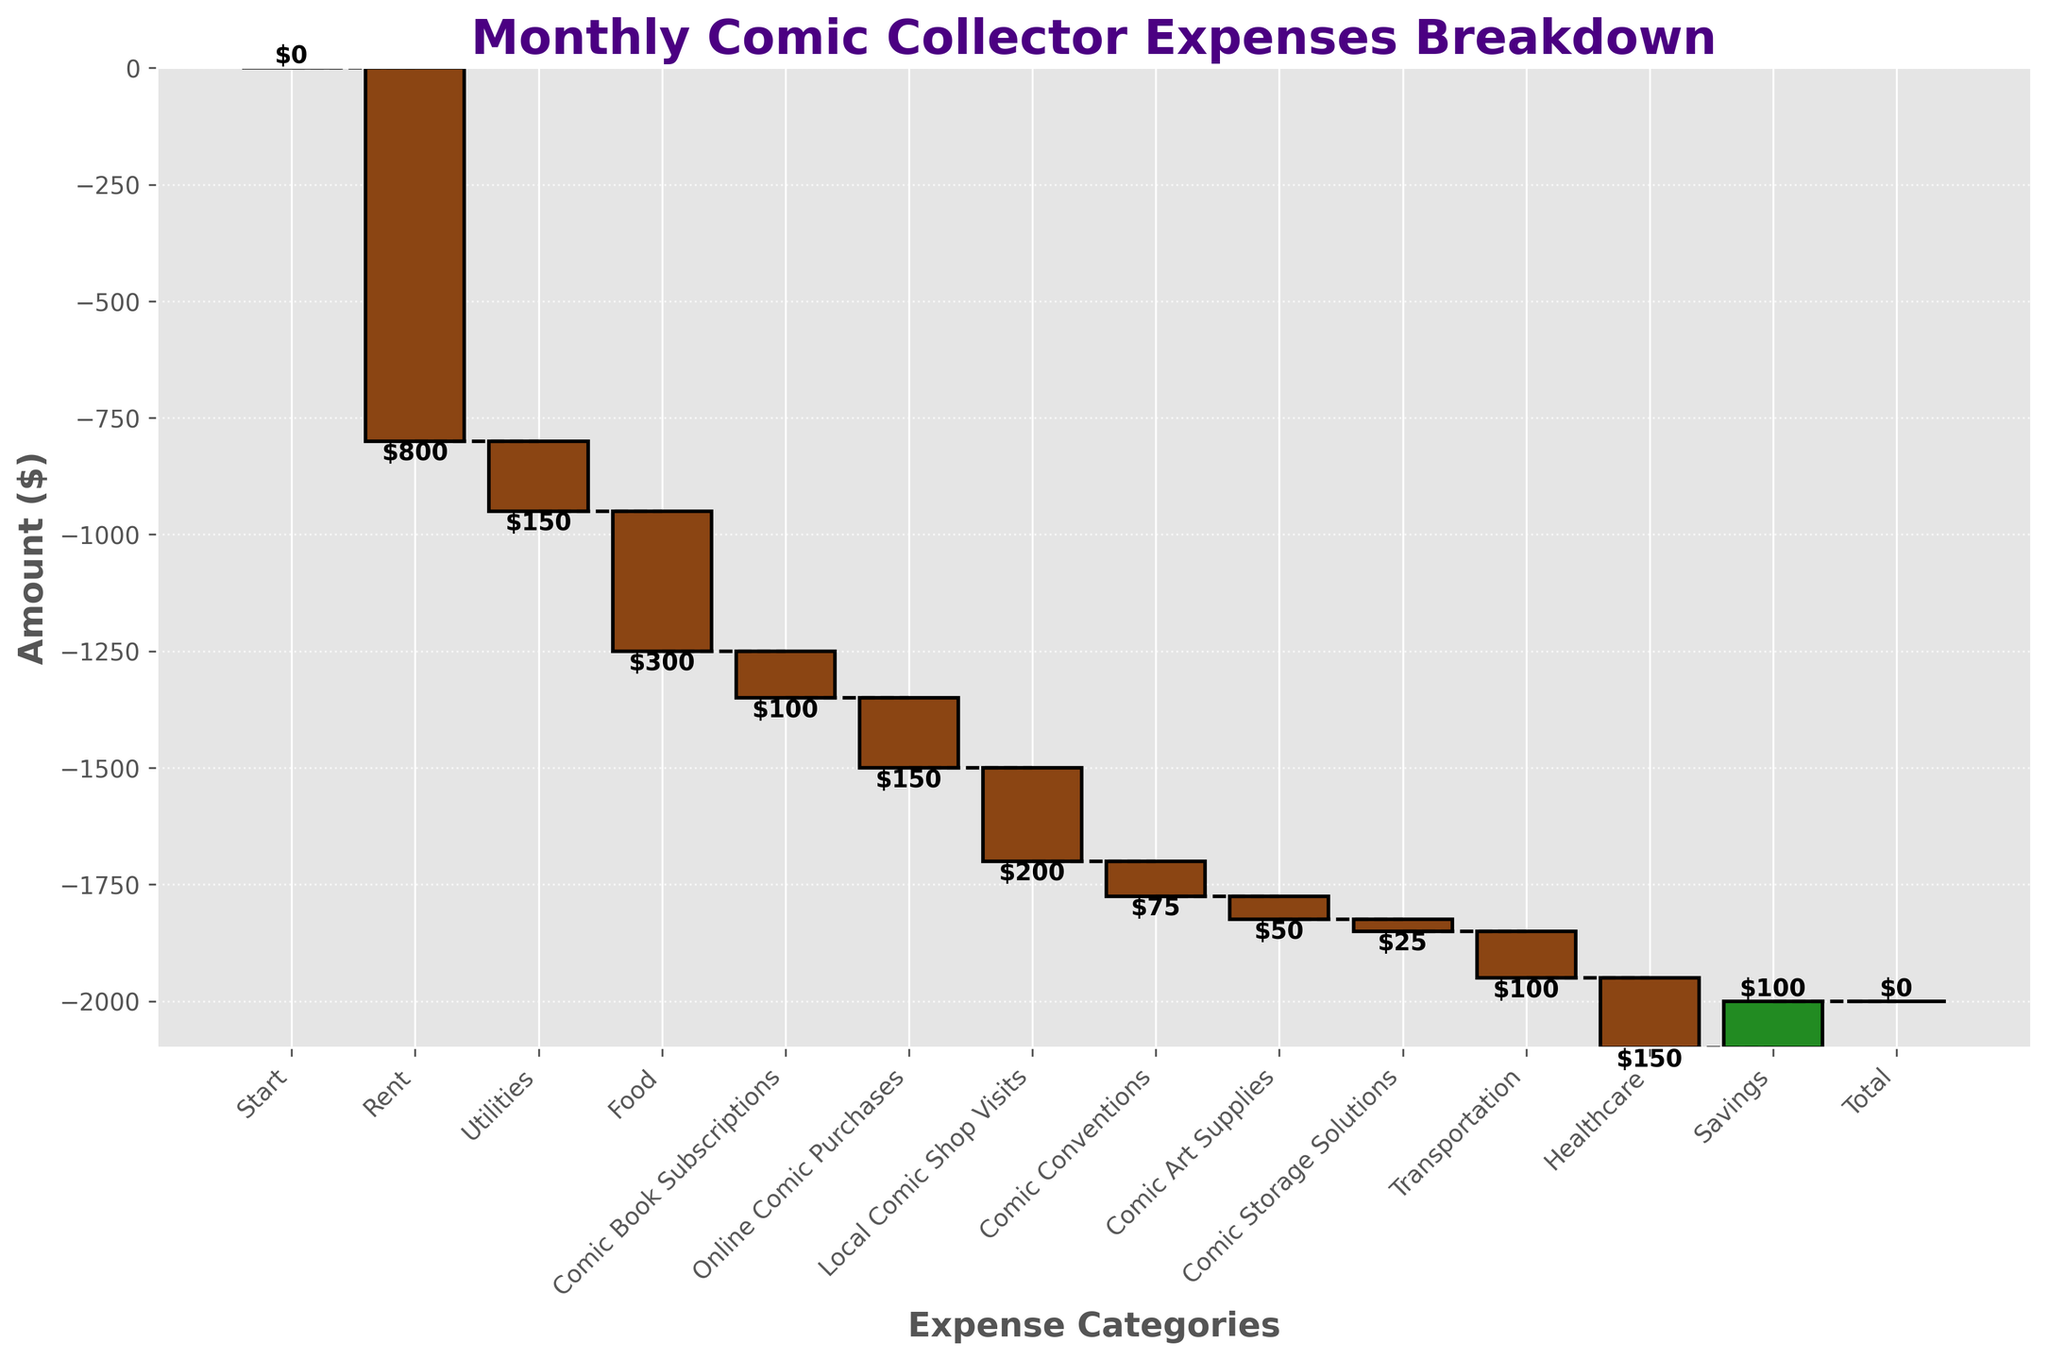What is the title of the chart? The title of the chart is found at the top part of the figure. It summarizes the entire plot.
Answer: Monthly Comic Collector Expenses Breakdown How many categories have negative amounts? By counting the bars with negative values, which are often represented in a different color, we can determine the number of categories with negative amounts.
Answer: 10 categories Which expense category contributes the most negative amount? Examine the bars and identify the one with the highest negative value (the longest bar pointing downwards).
Answer: Rent What is the cumulative expense after accounting for all online comic purchases? To find the cumulative expense, add up all the amounts up to and including the "Online Comic Purchases" category. The individual contributions can be traced from the start to this specific point.
Answer: -1500 How does the amount spent on comic conventions compare to comic book subscriptions? Compare the lengths of the two bars representing these categories or their labeled amounts.
Answer: Comic Conventions is $25 less What is the total negative spending for the categories related to comics? Sum the absolute values of the negative amounts for categories including "Comic Book Subscriptions", "Online Comic Purchases", "Local Comic Shop Visits", "Comic Conventions", "Comic Art Supplies", and "Comic Storage Solutions".
Answer: $600 By how much does the spending on transportation exceed healthcare spending? Calculate the difference between the amounts spent on transportation and healthcare by examining their respective bars and amounts.
Answer: $50 less Which category has the least negative impact on the total spending? Identify the shortest bar among those with negative values.
Answer: Comic Storage Solutions What is the net total after rent and utilities? Sum the values of the "Rent" and "Utilities" categories and then add them to the starting value of 0.
Answer: -950 What is the effect of savings on the cumulative amount? The impact of savings can be assessed by looking at the specific amount and its influence on the cumulative sum, especially after all previous negative values.
Answer: It increases the cumulative amount by $100 